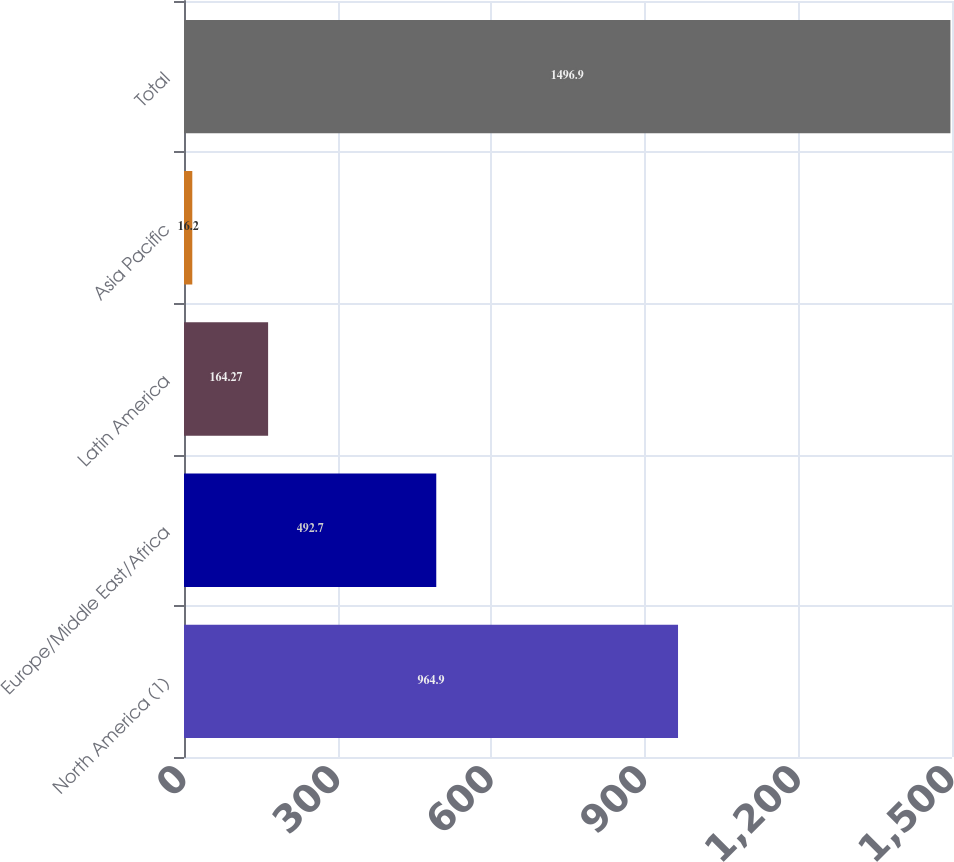<chart> <loc_0><loc_0><loc_500><loc_500><bar_chart><fcel>North America (1)<fcel>Europe/Middle East/Africa<fcel>Latin America<fcel>Asia Pacific<fcel>Total<nl><fcel>964.9<fcel>492.7<fcel>164.27<fcel>16.2<fcel>1496.9<nl></chart> 